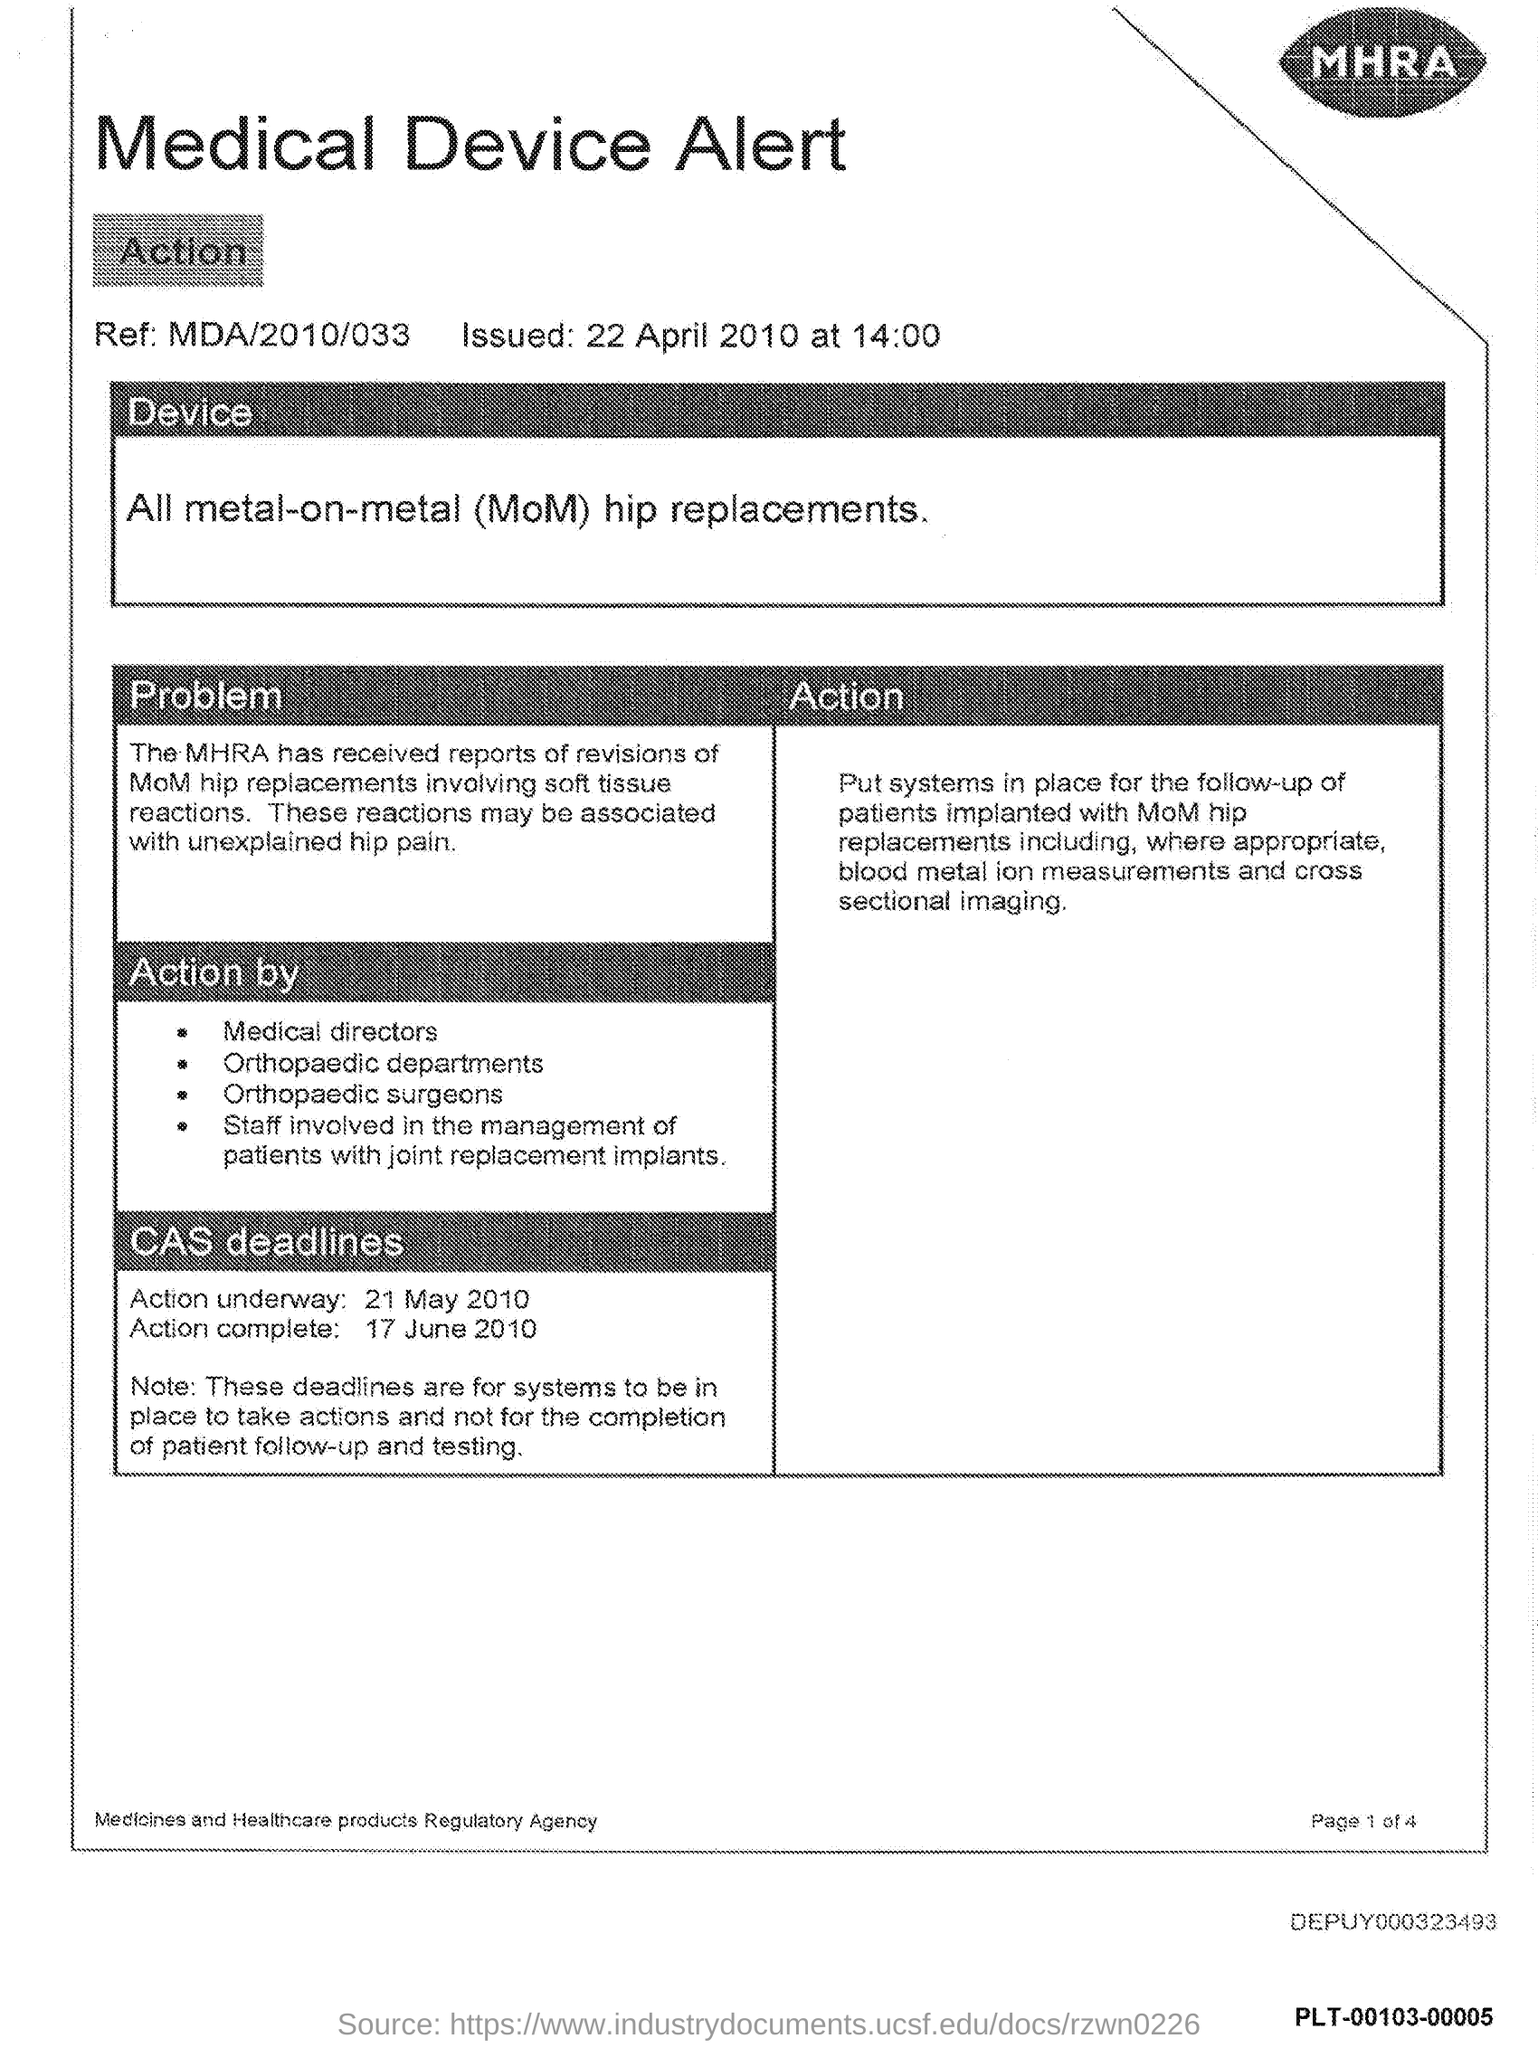Identify some key points in this picture. The reference number is "MDA/2010/033..". The date of Action Complete is June 17, 2010. The date of Action Underway is May 21st, 2010. 